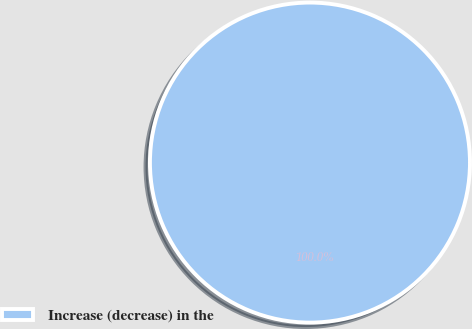Convert chart. <chart><loc_0><loc_0><loc_500><loc_500><pie_chart><fcel>Increase (decrease) in the<nl><fcel>100.0%<nl></chart> 